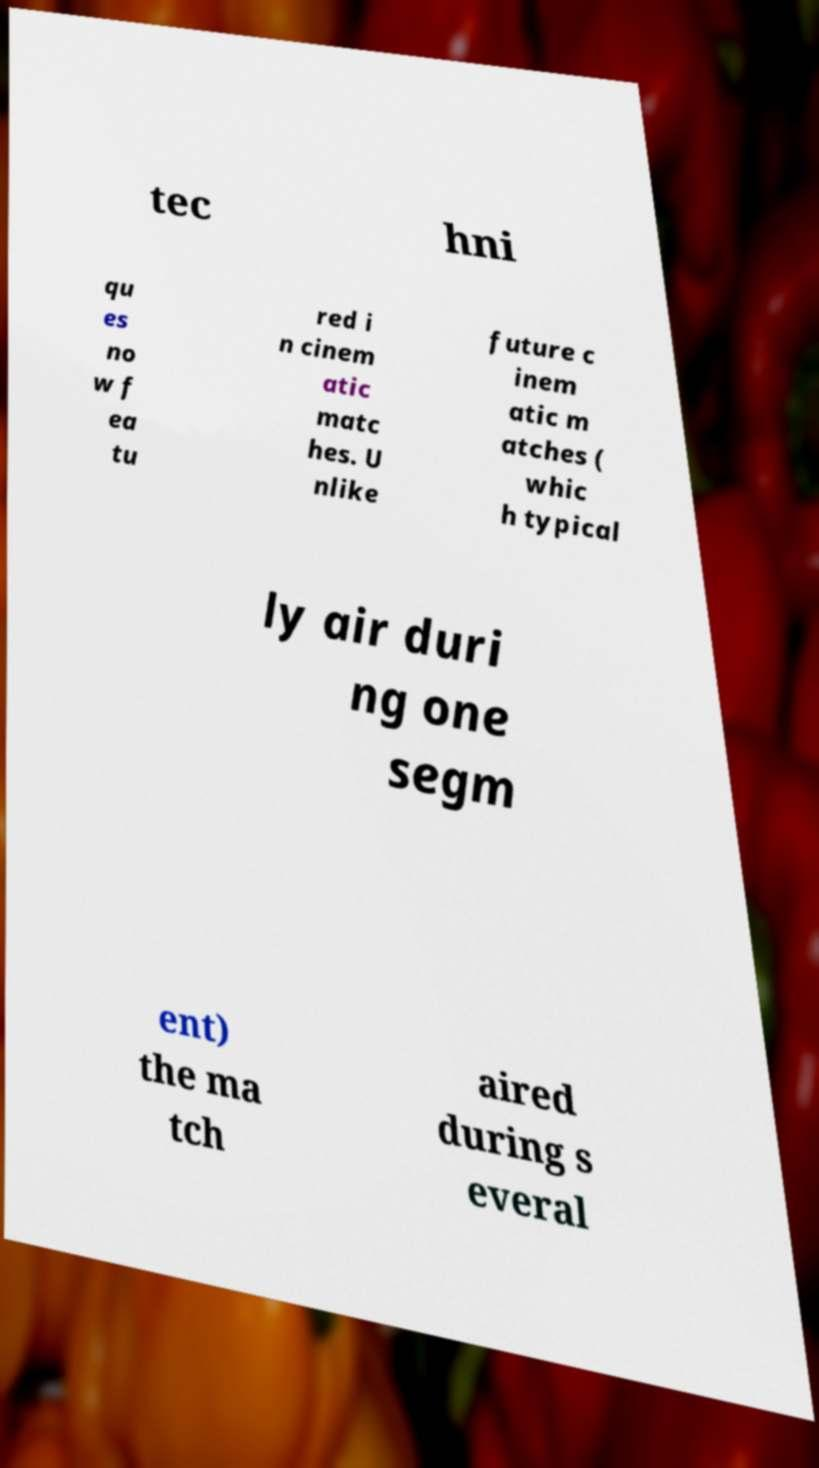I need the written content from this picture converted into text. Can you do that? tec hni qu es no w f ea tu red i n cinem atic matc hes. U nlike future c inem atic m atches ( whic h typical ly air duri ng one segm ent) the ma tch aired during s everal 